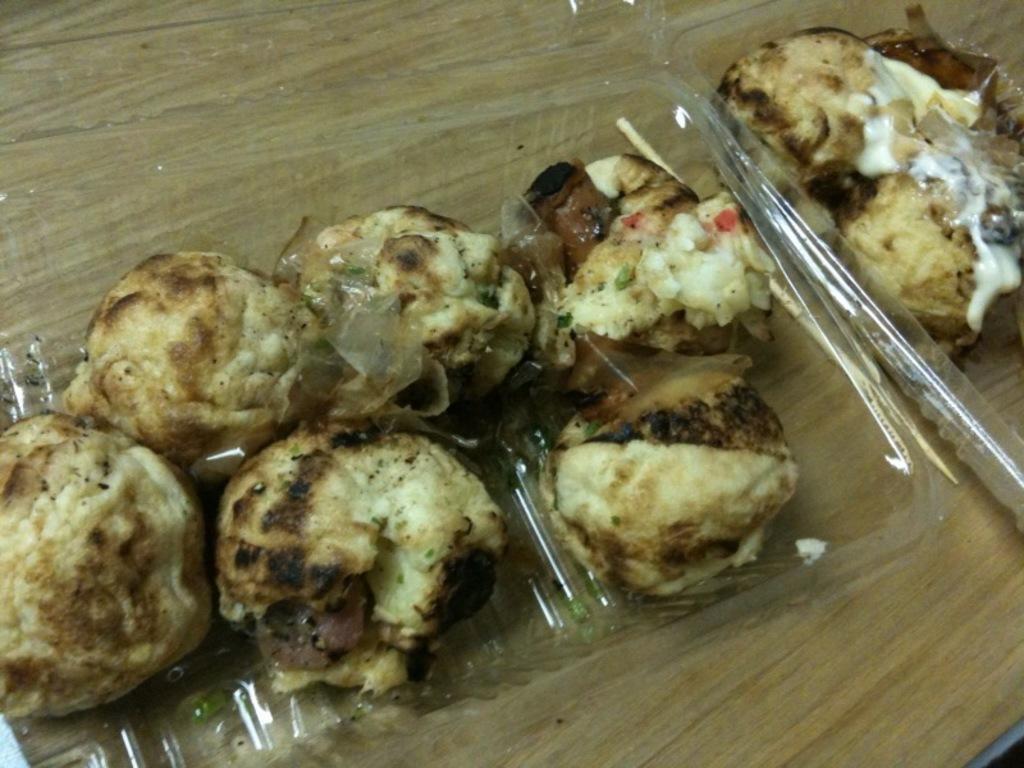What is on the plate that is visible in the image? There is food on a plate in the image. Where is the plate with food located? The plate with food is placed on a table. What type of books can be seen in the library in the image? There is no library present in the image; it only features a plate of food on a table. 